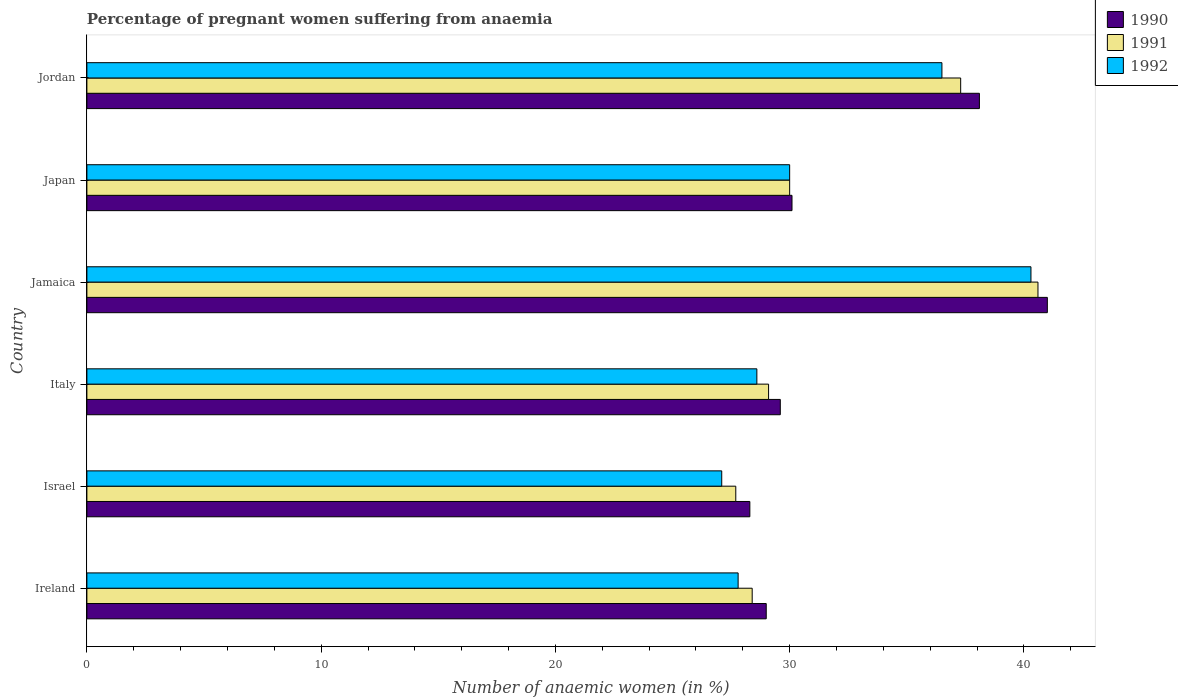Are the number of bars per tick equal to the number of legend labels?
Your answer should be compact. Yes. How many bars are there on the 4th tick from the top?
Give a very brief answer. 3. How many bars are there on the 1st tick from the bottom?
Your response must be concise. 3. In how many cases, is the number of bars for a given country not equal to the number of legend labels?
Your response must be concise. 0. What is the number of anaemic women in 1990 in Jordan?
Provide a short and direct response. 38.1. Across all countries, what is the minimum number of anaemic women in 1991?
Provide a short and direct response. 27.7. In which country was the number of anaemic women in 1991 maximum?
Your response must be concise. Jamaica. In which country was the number of anaemic women in 1991 minimum?
Ensure brevity in your answer.  Israel. What is the total number of anaemic women in 1992 in the graph?
Keep it short and to the point. 190.3. What is the difference between the number of anaemic women in 1991 in Ireland and that in Jamaica?
Offer a terse response. -12.2. What is the average number of anaemic women in 1991 per country?
Provide a succinct answer. 32.18. What is the difference between the number of anaemic women in 1992 and number of anaemic women in 1990 in Jordan?
Provide a succinct answer. -1.6. What is the ratio of the number of anaemic women in 1990 in Israel to that in Japan?
Make the answer very short. 0.94. What is the difference between the highest and the second highest number of anaemic women in 1991?
Ensure brevity in your answer.  3.3. What is the difference between the highest and the lowest number of anaemic women in 1991?
Offer a terse response. 12.9. In how many countries, is the number of anaemic women in 1991 greater than the average number of anaemic women in 1991 taken over all countries?
Ensure brevity in your answer.  2. Is the sum of the number of anaemic women in 1990 in Japan and Jordan greater than the maximum number of anaemic women in 1992 across all countries?
Give a very brief answer. Yes. What does the 1st bar from the top in Jordan represents?
Provide a succinct answer. 1992. Is it the case that in every country, the sum of the number of anaemic women in 1992 and number of anaemic women in 1990 is greater than the number of anaemic women in 1991?
Provide a short and direct response. Yes. Are all the bars in the graph horizontal?
Provide a short and direct response. Yes. What is the difference between two consecutive major ticks on the X-axis?
Your response must be concise. 10. Are the values on the major ticks of X-axis written in scientific E-notation?
Your answer should be compact. No. Does the graph contain grids?
Give a very brief answer. No. Where does the legend appear in the graph?
Provide a short and direct response. Top right. What is the title of the graph?
Your response must be concise. Percentage of pregnant women suffering from anaemia. Does "1997" appear as one of the legend labels in the graph?
Give a very brief answer. No. What is the label or title of the X-axis?
Your answer should be very brief. Number of anaemic women (in %). What is the label or title of the Y-axis?
Your answer should be very brief. Country. What is the Number of anaemic women (in %) of 1990 in Ireland?
Make the answer very short. 29. What is the Number of anaemic women (in %) of 1991 in Ireland?
Keep it short and to the point. 28.4. What is the Number of anaemic women (in %) of 1992 in Ireland?
Ensure brevity in your answer.  27.8. What is the Number of anaemic women (in %) in 1990 in Israel?
Keep it short and to the point. 28.3. What is the Number of anaemic women (in %) of 1991 in Israel?
Make the answer very short. 27.7. What is the Number of anaemic women (in %) of 1992 in Israel?
Offer a terse response. 27.1. What is the Number of anaemic women (in %) in 1990 in Italy?
Your response must be concise. 29.6. What is the Number of anaemic women (in %) of 1991 in Italy?
Make the answer very short. 29.1. What is the Number of anaemic women (in %) in 1992 in Italy?
Your response must be concise. 28.6. What is the Number of anaemic women (in %) of 1990 in Jamaica?
Offer a very short reply. 41. What is the Number of anaemic women (in %) in 1991 in Jamaica?
Give a very brief answer. 40.6. What is the Number of anaemic women (in %) of 1992 in Jamaica?
Provide a succinct answer. 40.3. What is the Number of anaemic women (in %) in 1990 in Japan?
Offer a very short reply. 30.1. What is the Number of anaemic women (in %) of 1991 in Japan?
Your answer should be very brief. 30. What is the Number of anaemic women (in %) in 1992 in Japan?
Your response must be concise. 30. What is the Number of anaemic women (in %) of 1990 in Jordan?
Keep it short and to the point. 38.1. What is the Number of anaemic women (in %) of 1991 in Jordan?
Give a very brief answer. 37.3. What is the Number of anaemic women (in %) of 1992 in Jordan?
Keep it short and to the point. 36.5. Across all countries, what is the maximum Number of anaemic women (in %) in 1991?
Ensure brevity in your answer.  40.6. Across all countries, what is the maximum Number of anaemic women (in %) of 1992?
Your response must be concise. 40.3. Across all countries, what is the minimum Number of anaemic women (in %) of 1990?
Give a very brief answer. 28.3. Across all countries, what is the minimum Number of anaemic women (in %) in 1991?
Your answer should be very brief. 27.7. Across all countries, what is the minimum Number of anaemic women (in %) of 1992?
Your answer should be very brief. 27.1. What is the total Number of anaemic women (in %) in 1990 in the graph?
Your response must be concise. 196.1. What is the total Number of anaemic women (in %) of 1991 in the graph?
Your answer should be very brief. 193.1. What is the total Number of anaemic women (in %) of 1992 in the graph?
Ensure brevity in your answer.  190.3. What is the difference between the Number of anaemic women (in %) in 1990 in Ireland and that in Israel?
Your answer should be compact. 0.7. What is the difference between the Number of anaemic women (in %) in 1991 in Ireland and that in Italy?
Offer a terse response. -0.7. What is the difference between the Number of anaemic women (in %) of 1990 in Ireland and that in Jamaica?
Provide a short and direct response. -12. What is the difference between the Number of anaemic women (in %) in 1990 in Ireland and that in Japan?
Your response must be concise. -1.1. What is the difference between the Number of anaemic women (in %) of 1991 in Ireland and that in Japan?
Keep it short and to the point. -1.6. What is the difference between the Number of anaemic women (in %) of 1992 in Ireland and that in Japan?
Make the answer very short. -2.2. What is the difference between the Number of anaemic women (in %) of 1990 in Ireland and that in Jordan?
Provide a short and direct response. -9.1. What is the difference between the Number of anaemic women (in %) in 1991 in Ireland and that in Jordan?
Your answer should be very brief. -8.9. What is the difference between the Number of anaemic women (in %) of 1992 in Ireland and that in Jordan?
Your answer should be compact. -8.7. What is the difference between the Number of anaemic women (in %) of 1991 in Israel and that in Jamaica?
Offer a very short reply. -12.9. What is the difference between the Number of anaemic women (in %) of 1990 in Israel and that in Japan?
Provide a succinct answer. -1.8. What is the difference between the Number of anaemic women (in %) of 1991 in Israel and that in Japan?
Provide a short and direct response. -2.3. What is the difference between the Number of anaemic women (in %) in 1992 in Israel and that in Jordan?
Give a very brief answer. -9.4. What is the difference between the Number of anaemic women (in %) in 1990 in Italy and that in Jamaica?
Your answer should be very brief. -11.4. What is the difference between the Number of anaemic women (in %) of 1991 in Italy and that in Japan?
Give a very brief answer. -0.9. What is the difference between the Number of anaemic women (in %) in 1992 in Jamaica and that in Japan?
Your answer should be very brief. 10.3. What is the difference between the Number of anaemic women (in %) of 1990 in Jamaica and that in Jordan?
Your answer should be very brief. 2.9. What is the difference between the Number of anaemic women (in %) of 1991 in Jamaica and that in Jordan?
Provide a short and direct response. 3.3. What is the difference between the Number of anaemic women (in %) of 1992 in Japan and that in Jordan?
Offer a terse response. -6.5. What is the difference between the Number of anaemic women (in %) in 1990 in Ireland and the Number of anaemic women (in %) in 1992 in Israel?
Make the answer very short. 1.9. What is the difference between the Number of anaemic women (in %) in 1990 in Ireland and the Number of anaemic women (in %) in 1991 in Italy?
Keep it short and to the point. -0.1. What is the difference between the Number of anaemic women (in %) in 1990 in Ireland and the Number of anaemic women (in %) in 1992 in Italy?
Offer a very short reply. 0.4. What is the difference between the Number of anaemic women (in %) of 1990 in Ireland and the Number of anaemic women (in %) of 1991 in Jamaica?
Offer a very short reply. -11.6. What is the difference between the Number of anaemic women (in %) in 1990 in Ireland and the Number of anaemic women (in %) in 1991 in Japan?
Provide a succinct answer. -1. What is the difference between the Number of anaemic women (in %) of 1990 in Ireland and the Number of anaemic women (in %) of 1992 in Jordan?
Offer a terse response. -7.5. What is the difference between the Number of anaemic women (in %) of 1991 in Ireland and the Number of anaemic women (in %) of 1992 in Jordan?
Offer a terse response. -8.1. What is the difference between the Number of anaemic women (in %) of 1990 in Israel and the Number of anaemic women (in %) of 1991 in Italy?
Offer a very short reply. -0.8. What is the difference between the Number of anaemic women (in %) of 1990 in Israel and the Number of anaemic women (in %) of 1992 in Italy?
Give a very brief answer. -0.3. What is the difference between the Number of anaemic women (in %) in 1991 in Israel and the Number of anaemic women (in %) in 1992 in Italy?
Your answer should be very brief. -0.9. What is the difference between the Number of anaemic women (in %) of 1990 in Israel and the Number of anaemic women (in %) of 1991 in Jamaica?
Provide a succinct answer. -12.3. What is the difference between the Number of anaemic women (in %) of 1990 in Israel and the Number of anaemic women (in %) of 1992 in Jamaica?
Offer a terse response. -12. What is the difference between the Number of anaemic women (in %) of 1991 in Israel and the Number of anaemic women (in %) of 1992 in Jamaica?
Ensure brevity in your answer.  -12.6. What is the difference between the Number of anaemic women (in %) in 1991 in Israel and the Number of anaemic women (in %) in 1992 in Japan?
Provide a short and direct response. -2.3. What is the difference between the Number of anaemic women (in %) in 1990 in Israel and the Number of anaemic women (in %) in 1991 in Jordan?
Keep it short and to the point. -9. What is the difference between the Number of anaemic women (in %) of 1991 in Israel and the Number of anaemic women (in %) of 1992 in Jordan?
Your answer should be compact. -8.8. What is the difference between the Number of anaemic women (in %) in 1990 in Italy and the Number of anaemic women (in %) in 1992 in Jamaica?
Your answer should be very brief. -10.7. What is the difference between the Number of anaemic women (in %) of 1990 in Italy and the Number of anaemic women (in %) of 1991 in Japan?
Your response must be concise. -0.4. What is the difference between the Number of anaemic women (in %) in 1991 in Italy and the Number of anaemic women (in %) in 1992 in Jordan?
Provide a succinct answer. -7.4. What is the difference between the Number of anaemic women (in %) of 1990 in Jamaica and the Number of anaemic women (in %) of 1991 in Japan?
Your response must be concise. 11. What is the difference between the Number of anaemic women (in %) of 1990 in Jamaica and the Number of anaemic women (in %) of 1992 in Jordan?
Give a very brief answer. 4.5. What is the difference between the Number of anaemic women (in %) in 1991 in Jamaica and the Number of anaemic women (in %) in 1992 in Jordan?
Provide a succinct answer. 4.1. What is the difference between the Number of anaemic women (in %) of 1990 in Japan and the Number of anaemic women (in %) of 1991 in Jordan?
Your answer should be compact. -7.2. What is the difference between the Number of anaemic women (in %) of 1990 in Japan and the Number of anaemic women (in %) of 1992 in Jordan?
Provide a succinct answer. -6.4. What is the average Number of anaemic women (in %) in 1990 per country?
Provide a short and direct response. 32.68. What is the average Number of anaemic women (in %) of 1991 per country?
Provide a short and direct response. 32.18. What is the average Number of anaemic women (in %) of 1992 per country?
Offer a terse response. 31.72. What is the difference between the Number of anaemic women (in %) of 1991 and Number of anaemic women (in %) of 1992 in Israel?
Ensure brevity in your answer.  0.6. What is the difference between the Number of anaemic women (in %) in 1990 and Number of anaemic women (in %) in 1991 in Italy?
Offer a very short reply. 0.5. What is the difference between the Number of anaemic women (in %) of 1990 and Number of anaemic women (in %) of 1992 in Italy?
Offer a terse response. 1. What is the difference between the Number of anaemic women (in %) of 1990 and Number of anaemic women (in %) of 1991 in Jamaica?
Your response must be concise. 0.4. What is the difference between the Number of anaemic women (in %) in 1990 and Number of anaemic women (in %) in 1991 in Japan?
Offer a very short reply. 0.1. What is the difference between the Number of anaemic women (in %) in 1990 and Number of anaemic women (in %) in 1992 in Japan?
Offer a very short reply. 0.1. What is the difference between the Number of anaemic women (in %) of 1991 and Number of anaemic women (in %) of 1992 in Japan?
Provide a succinct answer. 0. What is the difference between the Number of anaemic women (in %) in 1990 and Number of anaemic women (in %) in 1991 in Jordan?
Give a very brief answer. 0.8. What is the ratio of the Number of anaemic women (in %) in 1990 in Ireland to that in Israel?
Provide a short and direct response. 1.02. What is the ratio of the Number of anaemic women (in %) of 1991 in Ireland to that in Israel?
Provide a succinct answer. 1.03. What is the ratio of the Number of anaemic women (in %) in 1992 in Ireland to that in Israel?
Keep it short and to the point. 1.03. What is the ratio of the Number of anaemic women (in %) in 1990 in Ireland to that in Italy?
Offer a terse response. 0.98. What is the ratio of the Number of anaemic women (in %) in 1991 in Ireland to that in Italy?
Give a very brief answer. 0.98. What is the ratio of the Number of anaemic women (in %) in 1992 in Ireland to that in Italy?
Your answer should be very brief. 0.97. What is the ratio of the Number of anaemic women (in %) in 1990 in Ireland to that in Jamaica?
Your answer should be compact. 0.71. What is the ratio of the Number of anaemic women (in %) of 1991 in Ireland to that in Jamaica?
Provide a short and direct response. 0.7. What is the ratio of the Number of anaemic women (in %) of 1992 in Ireland to that in Jamaica?
Ensure brevity in your answer.  0.69. What is the ratio of the Number of anaemic women (in %) of 1990 in Ireland to that in Japan?
Your answer should be compact. 0.96. What is the ratio of the Number of anaemic women (in %) of 1991 in Ireland to that in Japan?
Keep it short and to the point. 0.95. What is the ratio of the Number of anaemic women (in %) in 1992 in Ireland to that in Japan?
Your answer should be compact. 0.93. What is the ratio of the Number of anaemic women (in %) in 1990 in Ireland to that in Jordan?
Give a very brief answer. 0.76. What is the ratio of the Number of anaemic women (in %) in 1991 in Ireland to that in Jordan?
Make the answer very short. 0.76. What is the ratio of the Number of anaemic women (in %) in 1992 in Ireland to that in Jordan?
Offer a very short reply. 0.76. What is the ratio of the Number of anaemic women (in %) in 1990 in Israel to that in Italy?
Your answer should be compact. 0.96. What is the ratio of the Number of anaemic women (in %) of 1991 in Israel to that in Italy?
Your answer should be very brief. 0.95. What is the ratio of the Number of anaemic women (in %) of 1992 in Israel to that in Italy?
Make the answer very short. 0.95. What is the ratio of the Number of anaemic women (in %) in 1990 in Israel to that in Jamaica?
Provide a short and direct response. 0.69. What is the ratio of the Number of anaemic women (in %) in 1991 in Israel to that in Jamaica?
Provide a succinct answer. 0.68. What is the ratio of the Number of anaemic women (in %) of 1992 in Israel to that in Jamaica?
Give a very brief answer. 0.67. What is the ratio of the Number of anaemic women (in %) of 1990 in Israel to that in Japan?
Your response must be concise. 0.94. What is the ratio of the Number of anaemic women (in %) in 1991 in Israel to that in Japan?
Offer a terse response. 0.92. What is the ratio of the Number of anaemic women (in %) of 1992 in Israel to that in Japan?
Ensure brevity in your answer.  0.9. What is the ratio of the Number of anaemic women (in %) in 1990 in Israel to that in Jordan?
Provide a short and direct response. 0.74. What is the ratio of the Number of anaemic women (in %) in 1991 in Israel to that in Jordan?
Offer a very short reply. 0.74. What is the ratio of the Number of anaemic women (in %) of 1992 in Israel to that in Jordan?
Offer a very short reply. 0.74. What is the ratio of the Number of anaemic women (in %) in 1990 in Italy to that in Jamaica?
Your response must be concise. 0.72. What is the ratio of the Number of anaemic women (in %) in 1991 in Italy to that in Jamaica?
Offer a terse response. 0.72. What is the ratio of the Number of anaemic women (in %) in 1992 in Italy to that in Jamaica?
Provide a succinct answer. 0.71. What is the ratio of the Number of anaemic women (in %) in 1990 in Italy to that in Japan?
Offer a very short reply. 0.98. What is the ratio of the Number of anaemic women (in %) in 1991 in Italy to that in Japan?
Keep it short and to the point. 0.97. What is the ratio of the Number of anaemic women (in %) of 1992 in Italy to that in Japan?
Your answer should be compact. 0.95. What is the ratio of the Number of anaemic women (in %) of 1990 in Italy to that in Jordan?
Your answer should be very brief. 0.78. What is the ratio of the Number of anaemic women (in %) in 1991 in Italy to that in Jordan?
Provide a succinct answer. 0.78. What is the ratio of the Number of anaemic women (in %) of 1992 in Italy to that in Jordan?
Ensure brevity in your answer.  0.78. What is the ratio of the Number of anaemic women (in %) in 1990 in Jamaica to that in Japan?
Ensure brevity in your answer.  1.36. What is the ratio of the Number of anaemic women (in %) of 1991 in Jamaica to that in Japan?
Make the answer very short. 1.35. What is the ratio of the Number of anaemic women (in %) of 1992 in Jamaica to that in Japan?
Provide a succinct answer. 1.34. What is the ratio of the Number of anaemic women (in %) of 1990 in Jamaica to that in Jordan?
Your response must be concise. 1.08. What is the ratio of the Number of anaemic women (in %) of 1991 in Jamaica to that in Jordan?
Give a very brief answer. 1.09. What is the ratio of the Number of anaemic women (in %) in 1992 in Jamaica to that in Jordan?
Keep it short and to the point. 1.1. What is the ratio of the Number of anaemic women (in %) in 1990 in Japan to that in Jordan?
Provide a succinct answer. 0.79. What is the ratio of the Number of anaemic women (in %) of 1991 in Japan to that in Jordan?
Give a very brief answer. 0.8. What is the ratio of the Number of anaemic women (in %) in 1992 in Japan to that in Jordan?
Your answer should be very brief. 0.82. What is the difference between the highest and the second highest Number of anaemic women (in %) in 1990?
Provide a short and direct response. 2.9. What is the difference between the highest and the second highest Number of anaemic women (in %) in 1992?
Your answer should be compact. 3.8. What is the difference between the highest and the lowest Number of anaemic women (in %) in 1991?
Your response must be concise. 12.9. What is the difference between the highest and the lowest Number of anaemic women (in %) of 1992?
Provide a short and direct response. 13.2. 